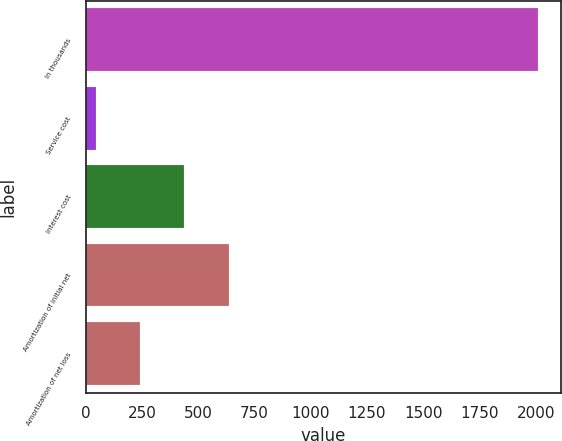Convert chart. <chart><loc_0><loc_0><loc_500><loc_500><bar_chart><fcel>In thousands<fcel>Service cost<fcel>Interest cost<fcel>Amortization of initial net<fcel>Amortization of net loss<nl><fcel>2012<fcel>45<fcel>438.4<fcel>635.1<fcel>241.7<nl></chart> 